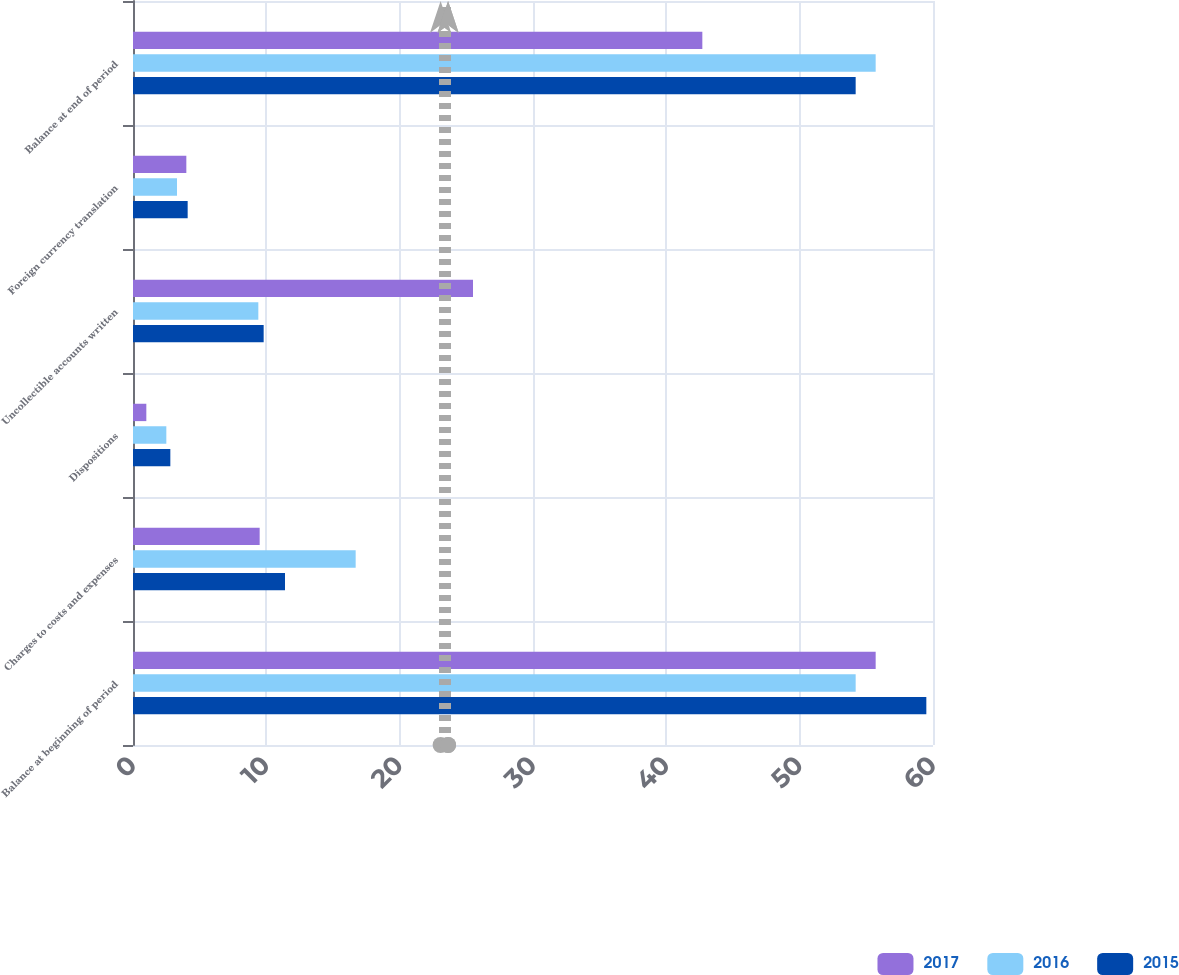Convert chart to OTSL. <chart><loc_0><loc_0><loc_500><loc_500><stacked_bar_chart><ecel><fcel>Balance at beginning of period<fcel>Charges to costs and expenses<fcel>Dispositions<fcel>Uncollectible accounts written<fcel>Foreign currency translation<fcel>Balance at end of period<nl><fcel>2017<fcel>55.7<fcel>9.5<fcel>1<fcel>25.5<fcel>4<fcel>42.7<nl><fcel>2016<fcel>54.2<fcel>16.7<fcel>2.5<fcel>9.4<fcel>3.3<fcel>55.7<nl><fcel>2015<fcel>59.5<fcel>11.4<fcel>2.8<fcel>9.8<fcel>4.1<fcel>54.2<nl></chart> 